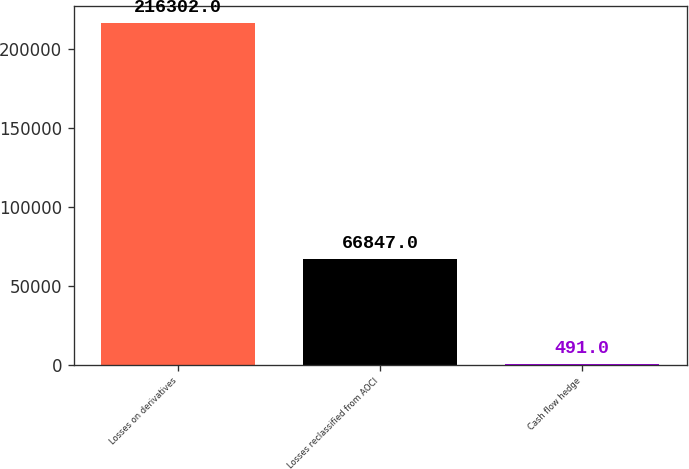Convert chart to OTSL. <chart><loc_0><loc_0><loc_500><loc_500><bar_chart><fcel>Losses on derivatives<fcel>Losses reclassified from AOCI<fcel>Cash flow hedge<nl><fcel>216302<fcel>66847<fcel>491<nl></chart> 